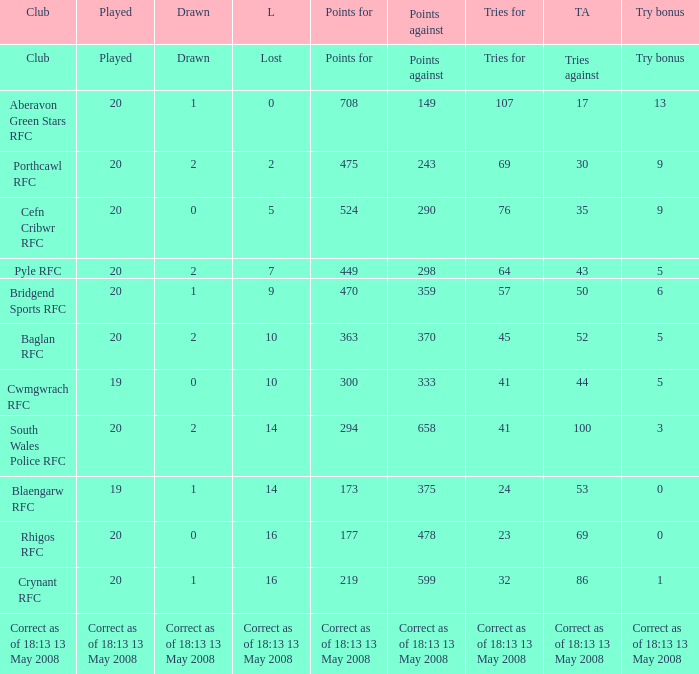What is the tries for when 52 was the tries against? 45.0. 